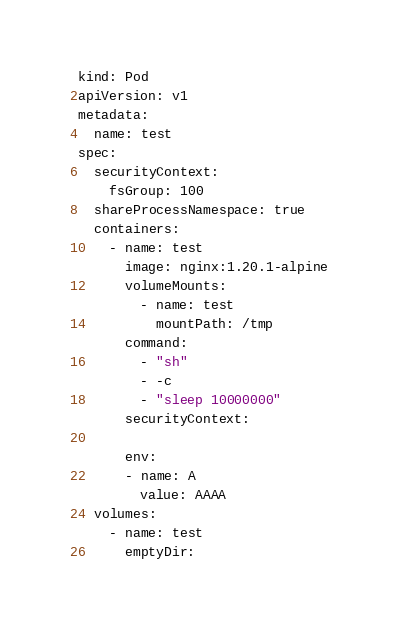Convert code to text. <code><loc_0><loc_0><loc_500><loc_500><_YAML_>kind: Pod
apiVersion: v1
metadata:
  name: test
spec:
  securityContext:
    fsGroup: 100
  shareProcessNamespace: true
  containers:
    - name: test
      image: nginx:1.20.1-alpine
      volumeMounts:
        - name: test
          mountPath: /tmp
      command:
        - "sh"
        - -c
        - "sleep 10000000"
      securityContext:

      env:
      - name: A
        value: AAAA
  volumes:
    - name: test
      emptyDir:
</code> 